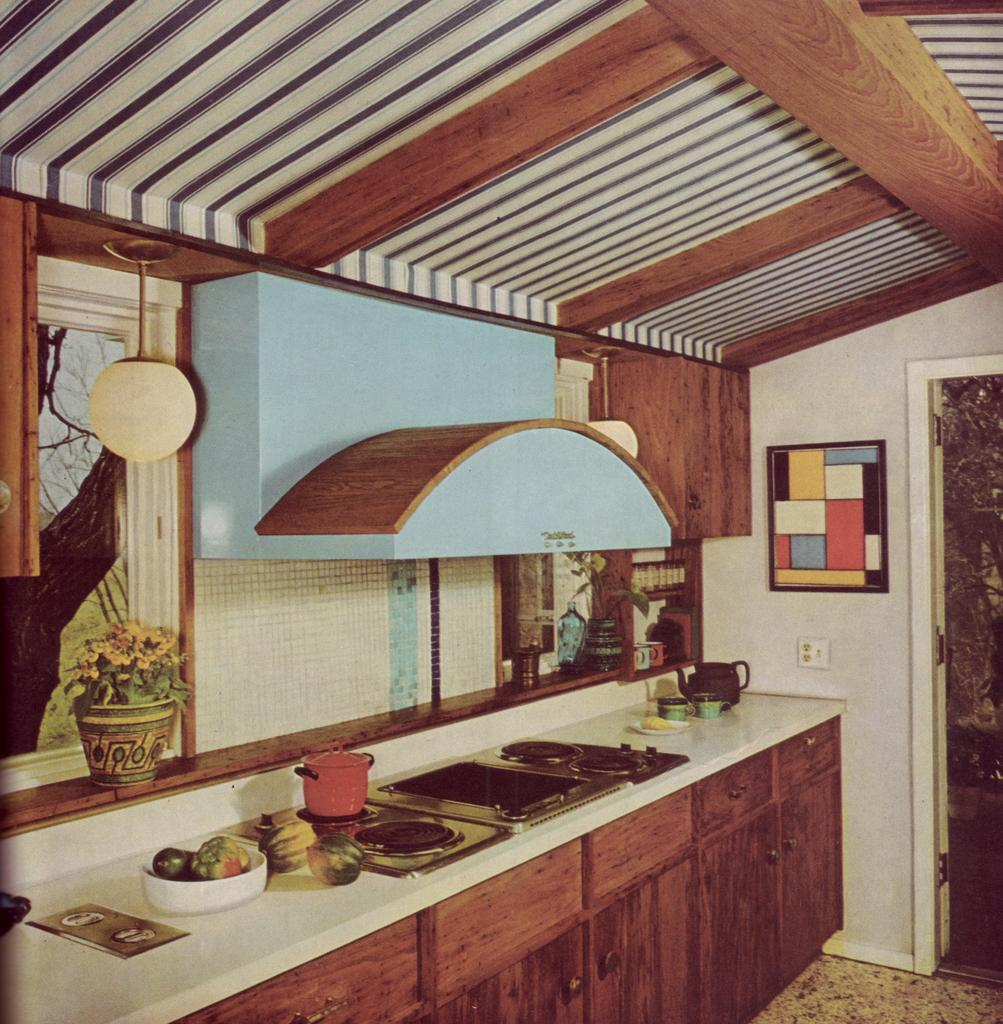What types of objects can be seen in the image? There are vessels, fruits, plants, a stove, a jug, cups, a window, a glass, a tree, a photo frame, a wall, and a door in the image. Can you describe the vegetation in the image? There are plants and trees in the image. What is the purpose of the stove in the image? The stove is likely used for cooking or heating. What can be seen through the window in the image? The image does not provide information about what can be seen through the window. What is the floor made of in the image? The facts do not specify the material of the floor. How many feet are visible in the image? There are no feet visible in the image. What type of quilt is draped over the tree in the image? There is no quilt present in the image. 